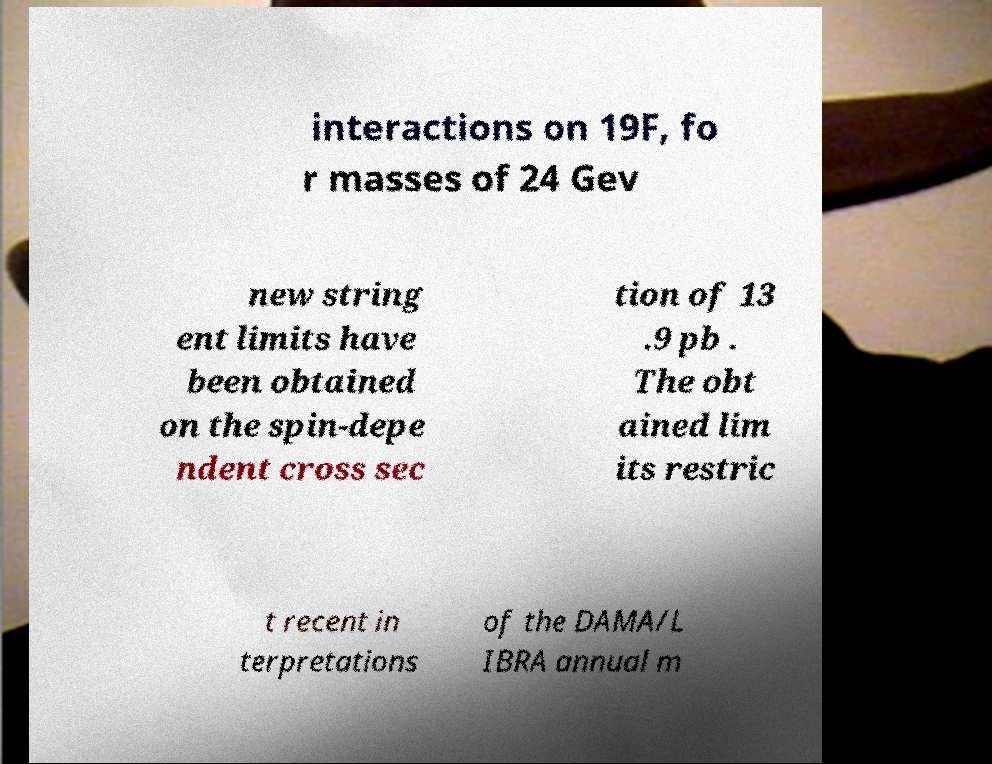Can you read and provide the text displayed in the image?This photo seems to have some interesting text. Can you extract and type it out for me? interactions on 19F, fo r masses of 24 Gev new string ent limits have been obtained on the spin-depe ndent cross sec tion of 13 .9 pb . The obt ained lim its restric t recent in terpretations of the DAMA/L IBRA annual m 